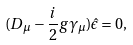Convert formula to latex. <formula><loc_0><loc_0><loc_500><loc_500>( D _ { \mu } - \frac { i } { 2 } g \gamma _ { \mu } ) \hat { \epsilon } = 0 ,</formula> 